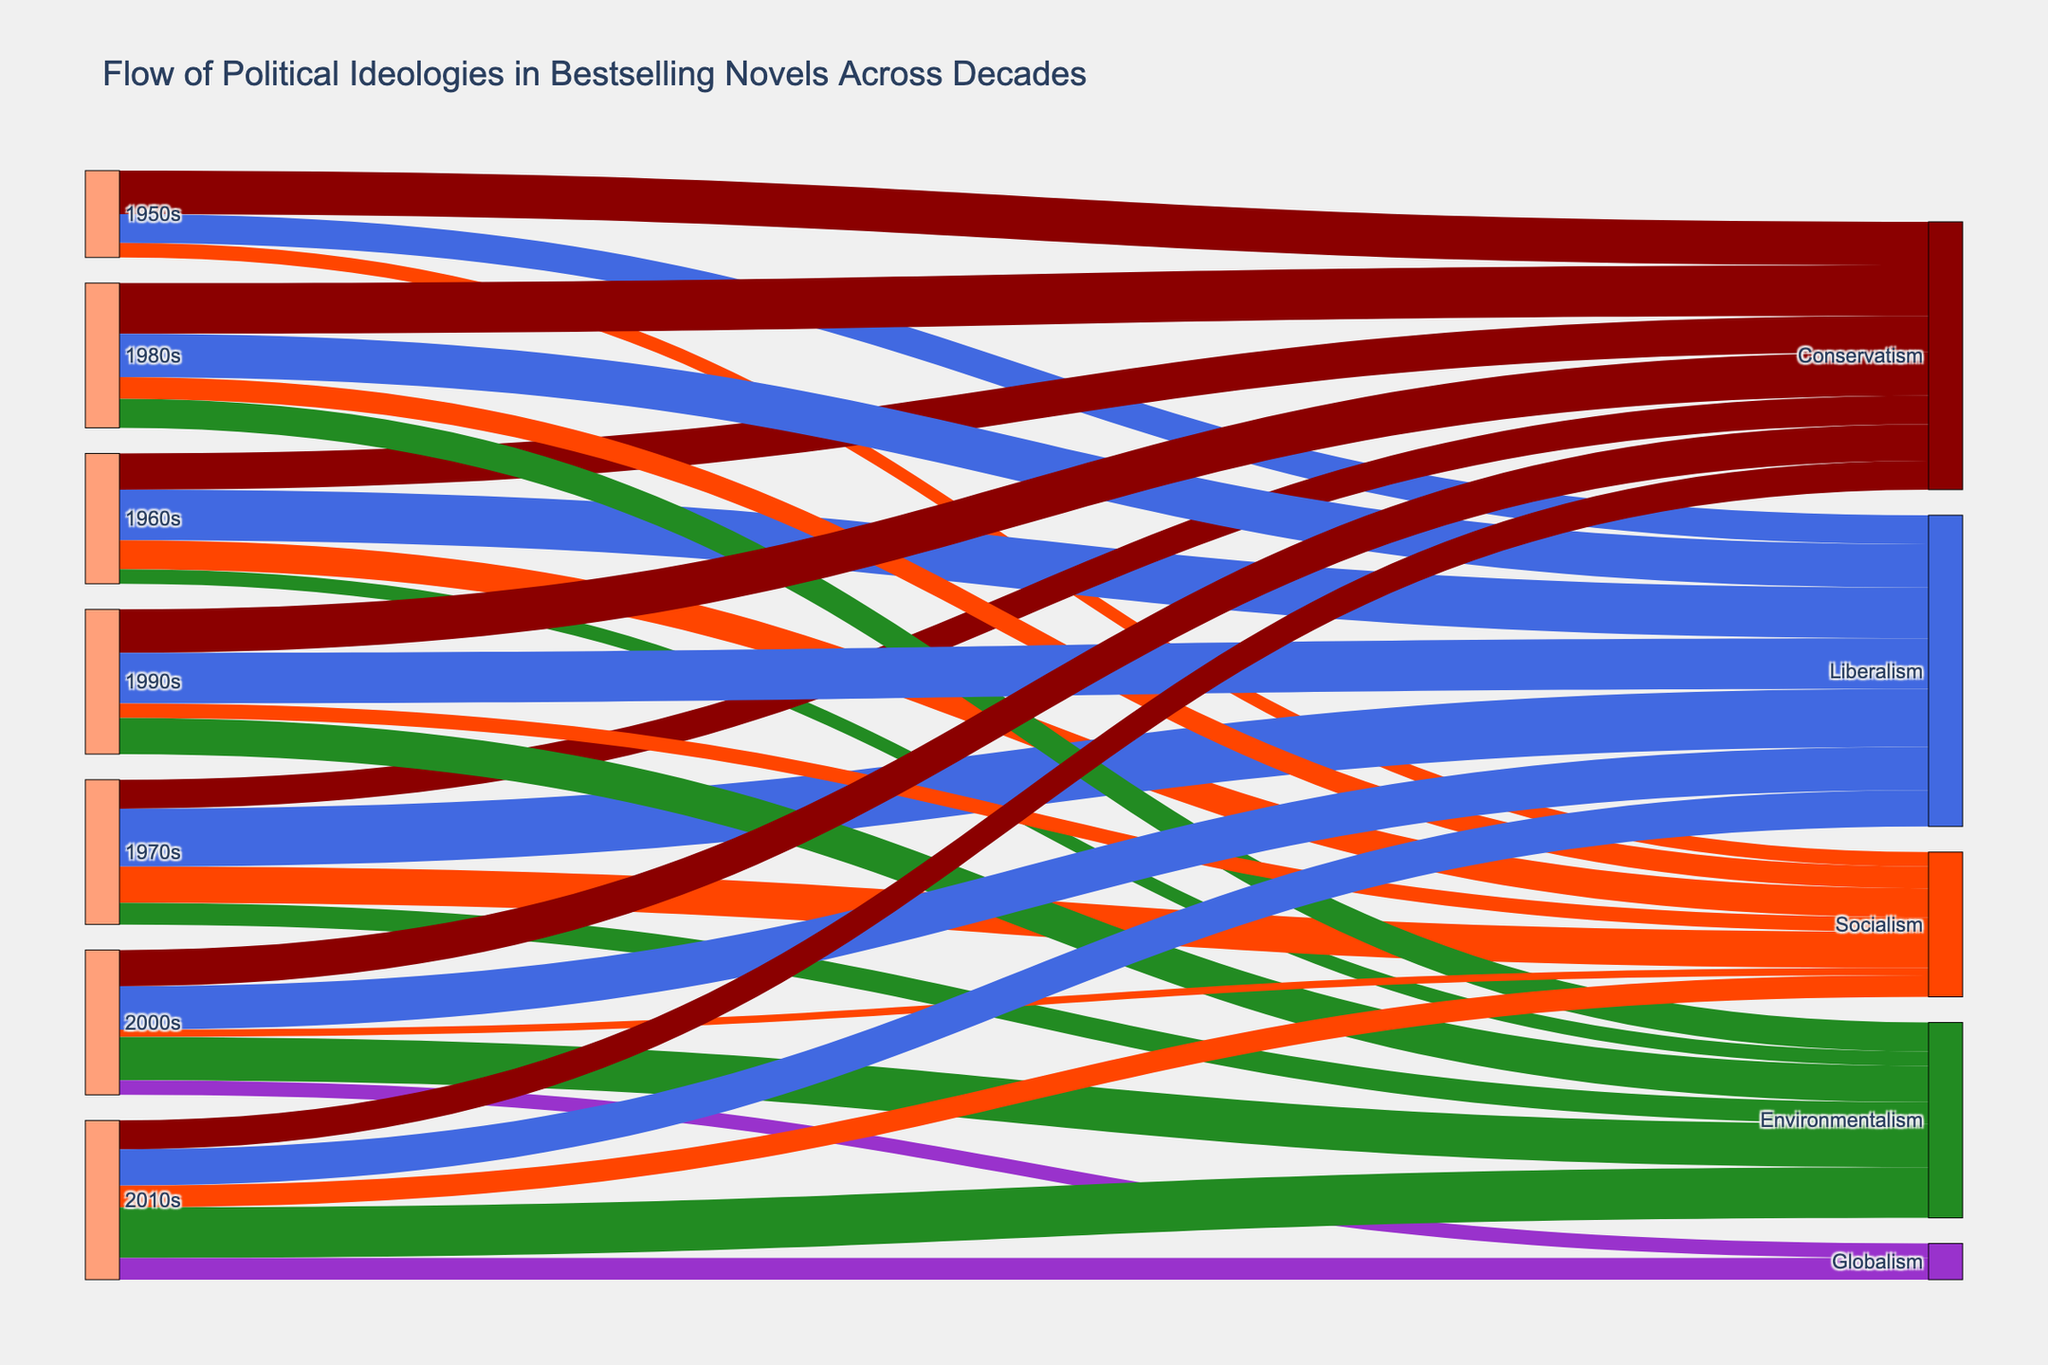How does the prominence of Conservatism change across the decades? To determine this, trace the size of the flows connected to Conservatism across each decade. Starting from the 1950s, we have: 30 in 1950s, 25 in 1960s, 20 in 1970s, 35 in 1980s, 30 in 1990s, 25 in 2000s, and 20 in 2010s. This shows a peak in the 1980s followed by a decline.
Answer: Peaks in the 1980s, then declines Which decade saw the highest value for Environmentalism? Look for the largest flow directed towards Environmentalism across all decades. The values are: 10 in 1960s, 15 in 1970s, 20 in 1980s, 25 in 1990s, 30 in 2000s, and 35 in 2010s. The highest value is in the 2010s with 35.
Answer: 2010s What is the combined value of Liberalism for the 1960s and 1990s? Sum the values of Liberalism for the 1960s and 1990s. In the 1960s, it's 35, and in the 1990s, it's 35. So, 35 + 35 = 70.
Answer: 70 Which ideology shows a consistent increase in value from the 1950s to the 2010s? Check each ideology: Conservatism, Liberalism, Socialism, Environmentalism, and Globalism. Only Environmentalism shows a consistent increase: 10 in 1960s, 15 in 1970s, 20 in 1980s, 25 in 1990s, 30 in 2000s, and 35 in 2010s.
Answer: Environmentalism How many political ideologies appear in the 2000s? Identify the unique targets for the 2000s. The ideologies are: Conservatism, Liberalism, Socialism, Environmentalism, and Globalism, which totals to 5.
Answer: 5 Compare the sum of values for Conservatism and Socialism over all decades. Which is higher? Sum the values for each ideology across all decades. Conservatism: 30+25+20+35+30+25+20 = 185. Socialism: 10+20+25+15+10+5+15 = 100. Conservatism is higher.
Answer: Conservatism What is the value difference for Globalism between the 2000s and 2010s? Subtract the value of Globalism in the 2000s from that in the 2010s. In the 2000s, it's 10, and in the 2010s, it's 15. The difference is 15 - 10 = 5.
Answer: 5 Which decade introduces the ideology of Globalism? Identify the first decade where Globalism appears. It first appears in the 2000s.
Answer: 2000s 